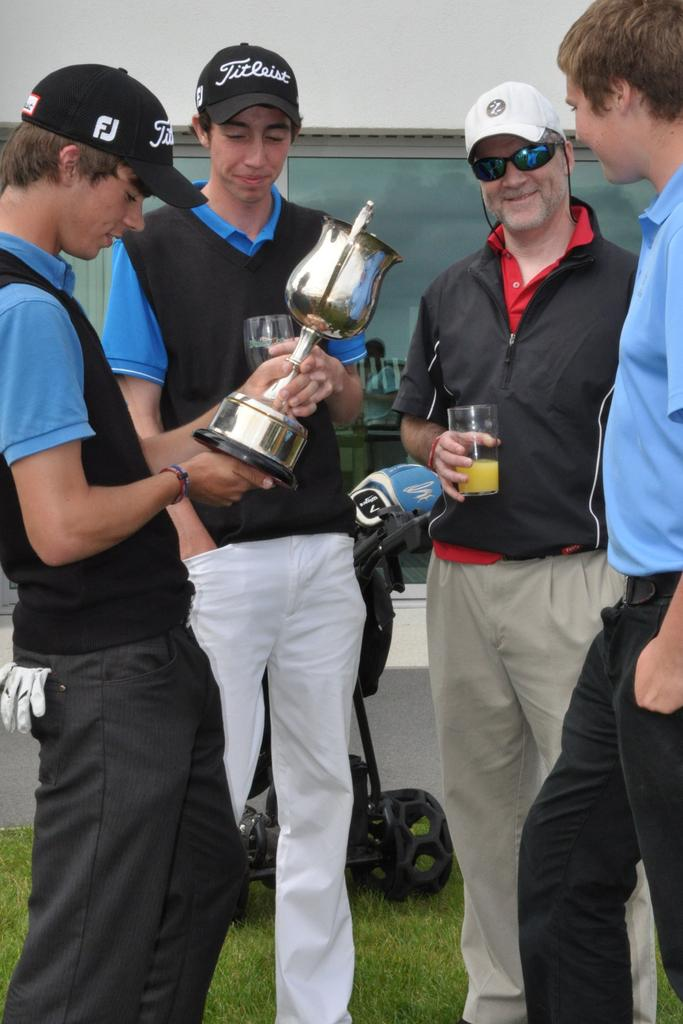Provide a one-sentence caption for the provided image. Four men stand around admiring a golf trophy, while one of them sports a hat labeled "Titleist.". 